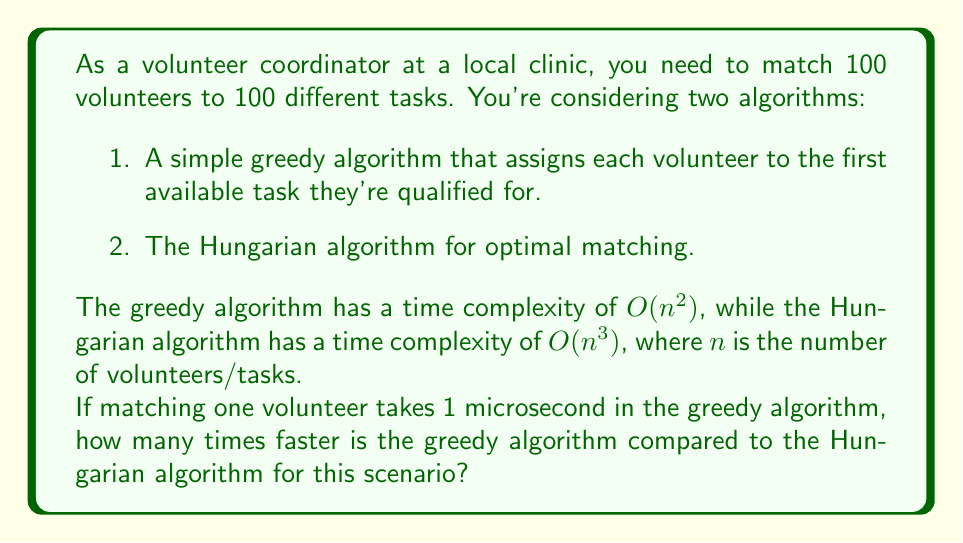Solve this math problem. Let's approach this step-by-step:

1) First, we need to calculate the time taken by each algorithm:

   Greedy Algorithm: 
   - Time complexity: $O(n^2)$
   - $n = 100$
   - Time = $100^2 \times 1\text{ µs} = 10,000\text{ µs}$

   Hungarian Algorithm:
   - Time complexity: $O(n^3)$
   - $n = 100$
   - Time = $100^3 \times 1\text{ µs} = 1,000,000\text{ µs}$

2) To find how many times faster the greedy algorithm is, we divide the time taken by the Hungarian algorithm by the time taken by the greedy algorithm:

   $$\frac{\text{Time (Hungarian)}}{\text{Time (Greedy)}} = \frac{1,000,000}{10,000} = 100$$

Therefore, for this scenario with 100 volunteers and tasks, the greedy algorithm is 100 times faster than the Hungarian algorithm.

Note: This comparison is based solely on asymptotic time complexity and doesn't account for the quality of the matching or other real-world factors that might influence algorithm choice.
Answer: The greedy algorithm is 100 times faster than the Hungarian algorithm for matching 100 volunteers to 100 tasks. 